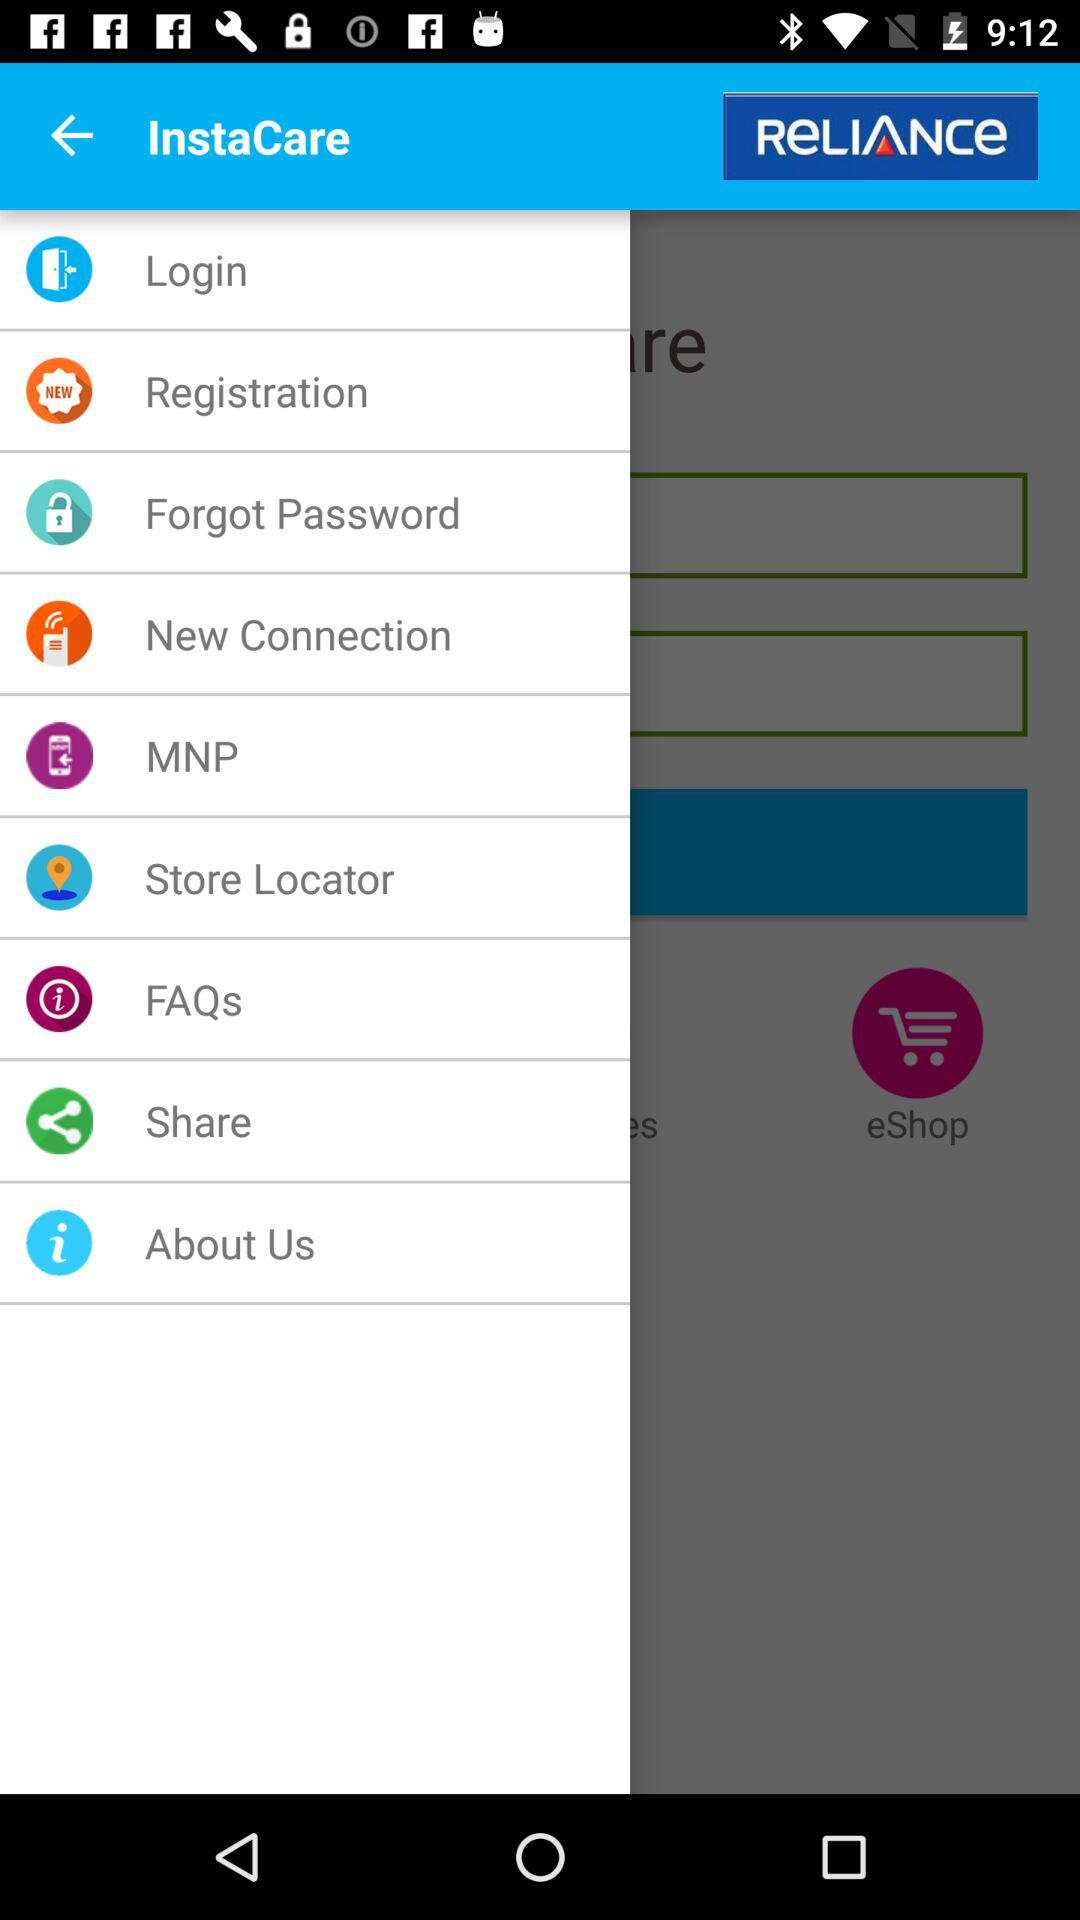What is the name of the application? The name of the application is "RELIANCE InstaCare". 